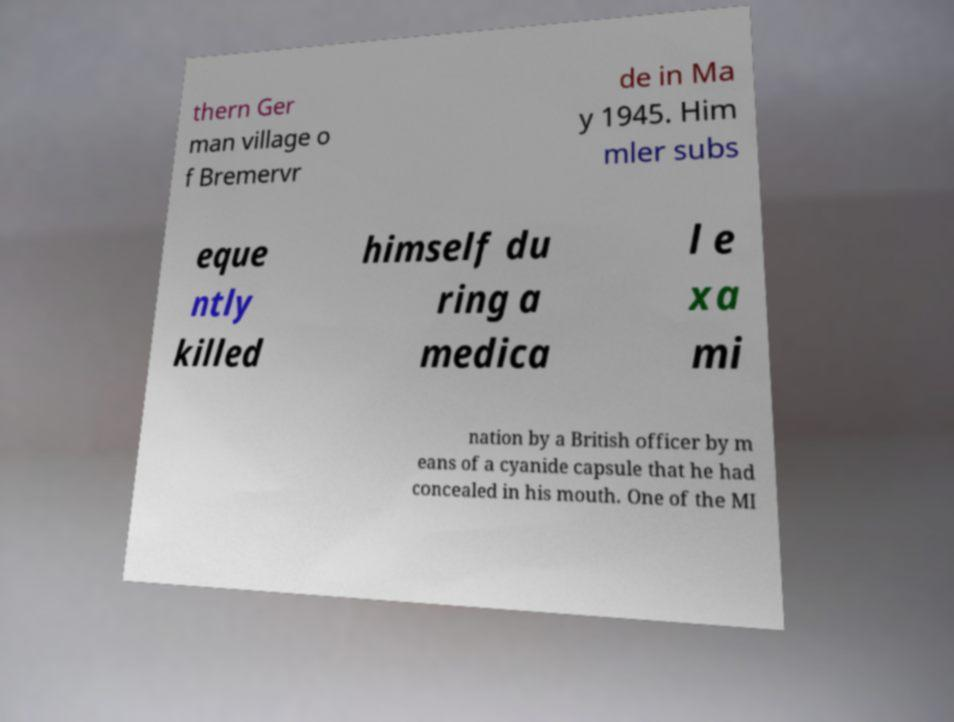For documentation purposes, I need the text within this image transcribed. Could you provide that? thern Ger man village o f Bremervr de in Ma y 1945. Him mler subs eque ntly killed himself du ring a medica l e xa mi nation by a British officer by m eans of a cyanide capsule that he had concealed in his mouth. One of the MI 